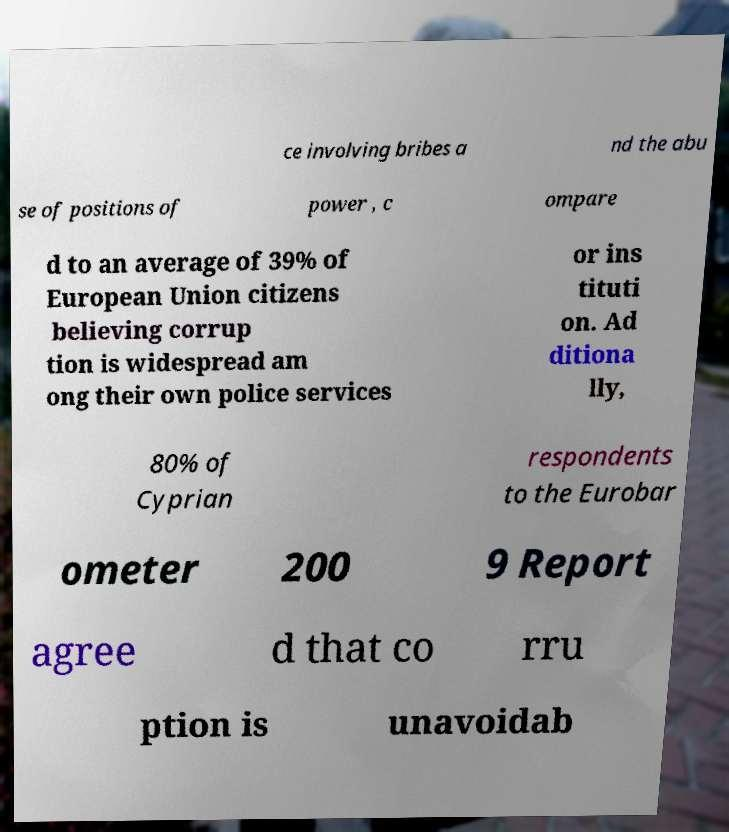Could you assist in decoding the text presented in this image and type it out clearly? ce involving bribes a nd the abu se of positions of power , c ompare d to an average of 39% of European Union citizens believing corrup tion is widespread am ong their own police services or ins tituti on. Ad ditiona lly, 80% of Cyprian respondents to the Eurobar ometer 200 9 Report agree d that co rru ption is unavoidab 